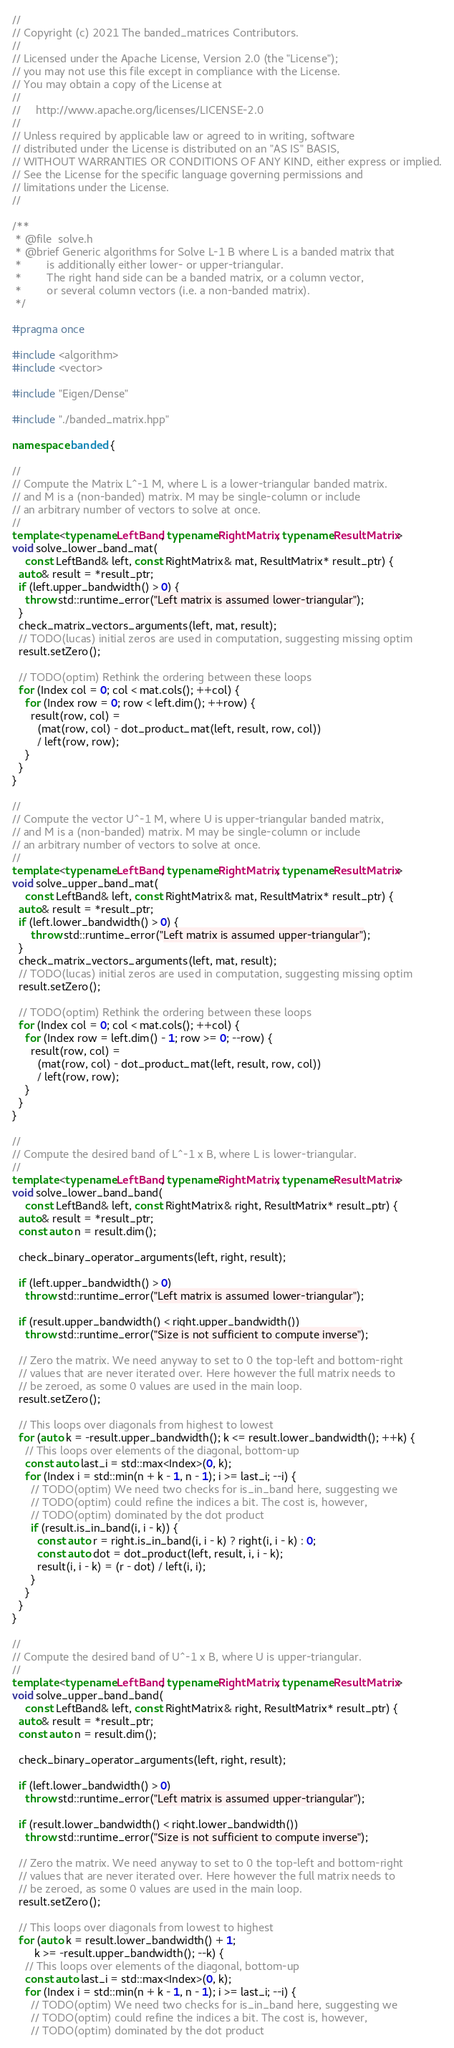<code> <loc_0><loc_0><loc_500><loc_500><_C++_>//
// Copyright (c) 2021 The banded_matrices Contributors.
//
// Licensed under the Apache License, Version 2.0 (the "License");
// you may not use this file except in compliance with the License.
// You may obtain a copy of the License at
//
//     http://www.apache.org/licenses/LICENSE-2.0
//
// Unless required by applicable law or agreed to in writing, software
// distributed under the License is distributed on an "AS IS" BASIS,
// WITHOUT WARRANTIES OR CONDITIONS OF ANY KIND, either express or implied.
// See the License for the specific language governing permissions and
// limitations under the License.
//

/**
 * @file  solve.h
 * @brief Generic algorithms for Solve L-1 B where L is a banded matrix that
 *        is additionally either lower- or upper-triangular.
 *        The right hand side can be a banded matrix, or a column vector,
 *        or several column vectors (i.e. a non-banded matrix).
 */

#pragma once

#include <algorithm>
#include <vector>

#include "Eigen/Dense"

#include "./banded_matrix.hpp"

namespace banded {

//
// Compute the Matrix L^-1 M, where L is a lower-triangular banded matrix.
// and M is a (non-banded) matrix. M may be single-column or include
// an arbitrary number of vectors to solve at once.
//
template <typename LeftBand, typename RightMatrix, typename ResultMatrix>
void solve_lower_band_mat(
    const LeftBand& left, const RightMatrix& mat, ResultMatrix* result_ptr) {
  auto& result = *result_ptr;
  if (left.upper_bandwidth() > 0) {
    throw std::runtime_error("Left matrix is assumed lower-triangular");
  }
  check_matrix_vectors_arguments(left, mat, result);
  // TODO(lucas) initial zeros are used in computation, suggesting missing optim
  result.setZero();

  // TODO(optim) Rethink the ordering between these loops
  for (Index col = 0; col < mat.cols(); ++col) {
    for (Index row = 0; row < left.dim(); ++row) {
      result(row, col) =
        (mat(row, col) - dot_product_mat(left, result, row, col))
        / left(row, row);
    }
  }
}

//
// Compute the vector U^-1 M, where U is upper-triangular banded matrix,
// and M is a (non-banded) matrix. M may be single-column or include
// an arbitrary number of vectors to solve at once.
//
template <typename LeftBand, typename RightMatrix, typename ResultMatrix>
void solve_upper_band_mat(
    const LeftBand& left, const RightMatrix& mat, ResultMatrix* result_ptr) {
  auto& result = *result_ptr;
  if (left.lower_bandwidth() > 0) {
      throw std::runtime_error("Left matrix is assumed upper-triangular");
  }
  check_matrix_vectors_arguments(left, mat, result);
  // TODO(lucas) initial zeros are used in computation, suggesting missing optim
  result.setZero();

  // TODO(optim) Rethink the ordering between these loops
  for (Index col = 0; col < mat.cols(); ++col) {
    for (Index row = left.dim() - 1; row >= 0; --row) {
      result(row, col) =
        (mat(row, col) - dot_product_mat(left, result, row, col))
        / left(row, row);
    }
  }
}

//
// Compute the desired band of L^-1 x B, where L is lower-triangular.
//
template <typename LeftBand, typename RightMatrix, typename ResultMatrix>
void solve_lower_band_band(
    const LeftBand& left, const RightMatrix& right, ResultMatrix* result_ptr) {
  auto& result = *result_ptr;
  const auto n = result.dim();

  check_binary_operator_arguments(left, right, result);

  if (left.upper_bandwidth() > 0)
    throw std::runtime_error("Left matrix is assumed lower-triangular");

  if (result.upper_bandwidth() < right.upper_bandwidth())
    throw std::runtime_error("Size is not sufficient to compute inverse");

  // Zero the matrix. We need anyway to set to 0 the top-left and bottom-right
  // values that are never iterated over. Here however the full matrix needs to
  // be zeroed, as some 0 values are used in the main loop.
  result.setZero();

  // This loops over diagonals from highest to lowest
  for (auto k = -result.upper_bandwidth(); k <= result.lower_bandwidth(); ++k) {
    // This loops over elements of the diagonal, bottom-up
    const auto last_i = std::max<Index>(0, k);
    for (Index i = std::min(n + k - 1, n - 1); i >= last_i; --i) {
      // TODO(optim) We need two checks for is_in_band here, suggesting we
      // TODO(optim) could refine the indices a bit. The cost is, however,
      // TODO(optim) dominated by the dot product
      if (result.is_in_band(i, i - k)) {
        const auto r = right.is_in_band(i, i - k) ? right(i, i - k) : 0;
        const auto dot = dot_product(left, result, i, i - k);
        result(i, i - k) = (r - dot) / left(i, i);
      }
    }
  }
}

//
// Compute the desired band of U^-1 x B, where U is upper-triangular.
//
template <typename LeftBand, typename RightMatrix, typename ResultMatrix>
void solve_upper_band_band(
    const LeftBand& left, const RightMatrix& right, ResultMatrix* result_ptr) {
  auto& result = *result_ptr;
  const auto n = result.dim();

  check_binary_operator_arguments(left, right, result);

  if (left.lower_bandwidth() > 0)
    throw std::runtime_error("Left matrix is assumed upper-triangular");

  if (result.lower_bandwidth() < right.lower_bandwidth())
    throw std::runtime_error("Size is not sufficient to compute inverse");

  // Zero the matrix. We need anyway to set to 0 the top-left and bottom-right
  // values that are never iterated over. Here however the full matrix needs to
  // be zeroed, as some 0 values are used in the main loop.
  result.setZero();

  // This loops over diagonals from lowest to highest
  for (auto k = result.lower_bandwidth() + 1;
       k >= -result.upper_bandwidth(); --k) {
    // This loops over elements of the diagonal, bottom-up
    const auto last_i = std::max<Index>(0, k);
    for (Index i = std::min(n + k - 1, n - 1); i >= last_i; --i) {
      // TODO(optim) We need two checks for is_in_band here, suggesting we
      // TODO(optim) could refine the indices a bit. The cost is, however,
      // TODO(optim) dominated by the dot product</code> 